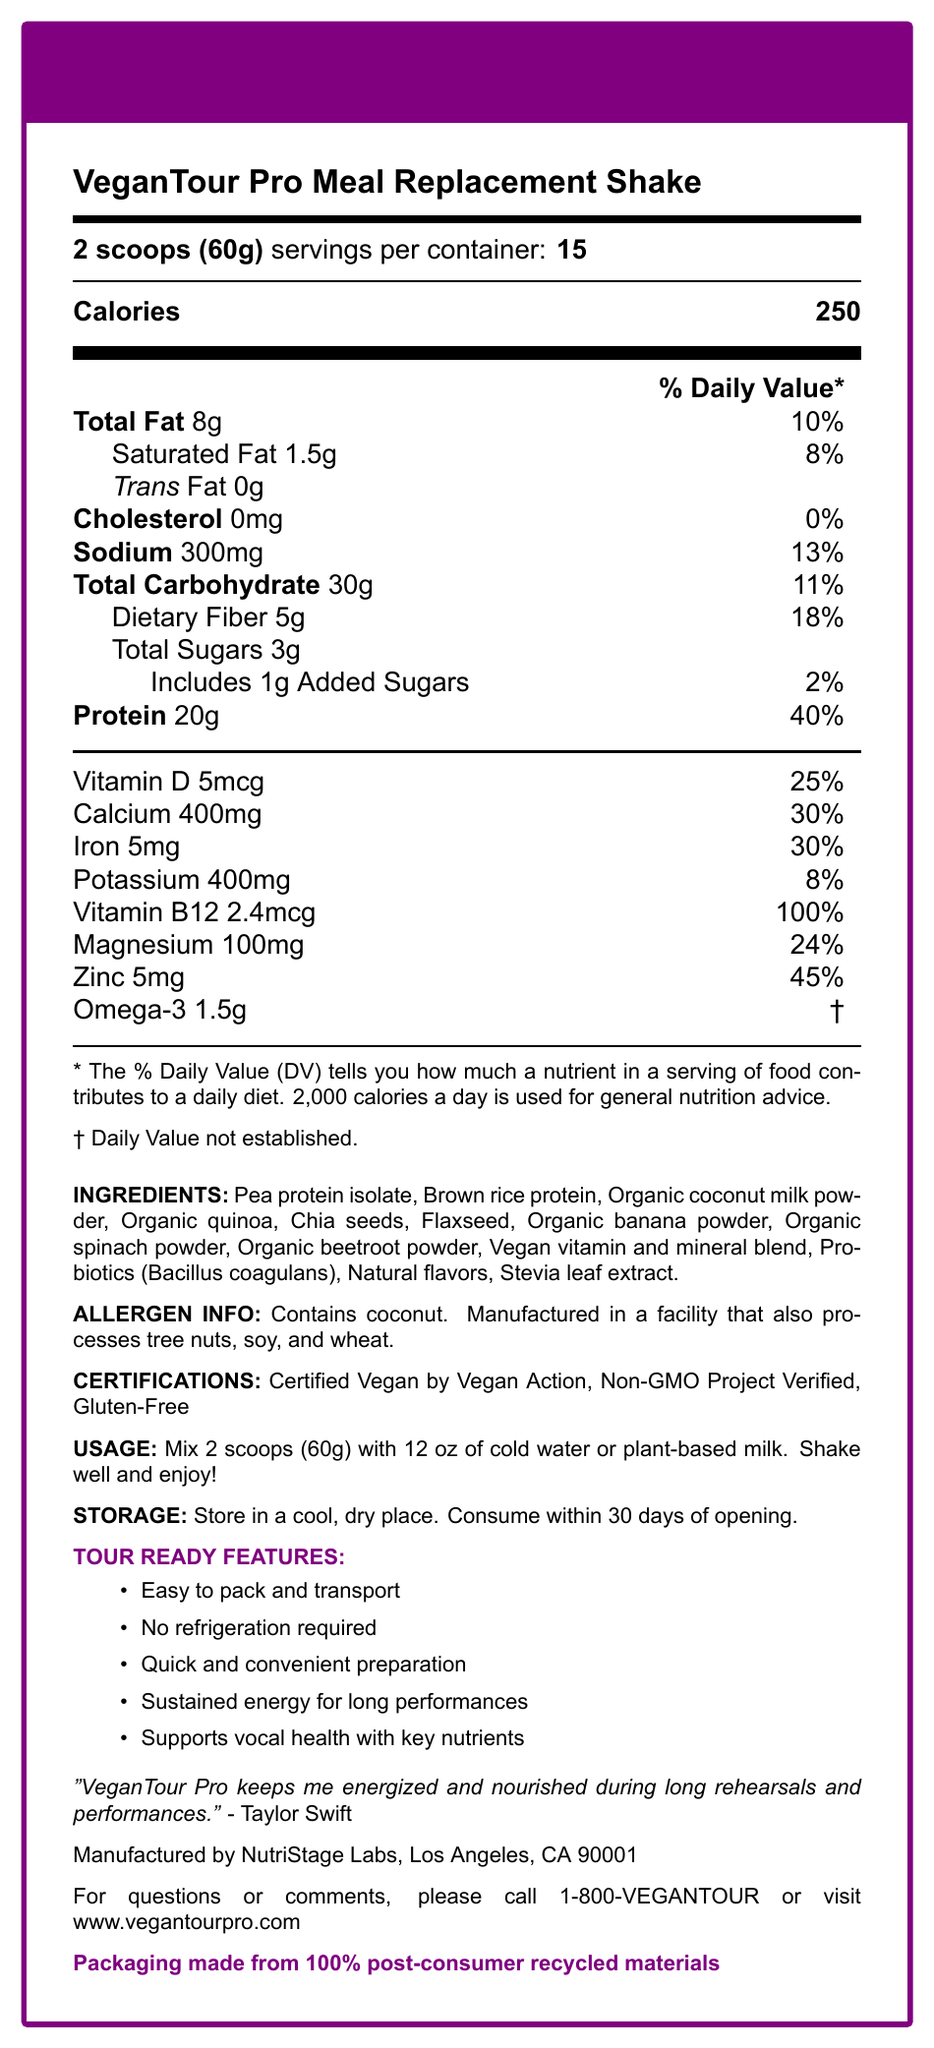what is the serving size for the VeganTour Pro Meal Replacement Shake? The serving size is explicitly mentioned as "2 scoops (60g)" in the document.
Answer: 2 scoops (60g) how many servings are there per container? The document states that there are 15 servings per container.
Answer: 15 what is the calorie count per serving? The calorie count per serving is listed as 250 in the document.
Answer: 250 how much protein does one serving contain? The protein content per serving is stated as 20g.
Answer: 20g how much sodium is in each serving? The sodium content per serving is indicated as 300mg.
Answer: 300mg what is the allergen information provided? The allergen information section states that the product contains coconut and is manufactured in a facility that also processes tree nuts, soy, and wheat.
Answer: Contains coconut. Manufactured in a facility that also processes tree nuts, soy, and wheat. what is the percentage of the Daily Value for Vitamin D in each serving? The document lists the Daily Value percentage for Vitamin D as 25%.
Answer: 25% which artist provided a testimonial for the VeganTour Pro Shake? A. Beyoncé B. Taylor Swift C. Katy Perry D. Lady Gaga The document includes a testimonial from Taylor Swift.
Answer: B what is the primary source of protein in the product? The ingredients list shows Pea protein isolate and Brown rice protein as the primary sources of protein.
Answer: Pea protein isolate and Brown rice protein which certification does the product have? A. USDA Organic B. Non-GMO Project Verified C. Gluten-Free D. B and C The document states that the product is Certified Vegan by Vegan Action, Non-GMO Project Verified, and Gluten-Free. Among the options, only B and C are listed.
Answer: D is this product suitable for vegans? The product is certified vegan as indicated by the certification section.
Answer: Yes how long can the product be consumed safely after opening? The storage instructions mention that the product should be consumed within 30 days of opening.
Answer: 30 days summarize the main features of the VeganTour Pro Meal Replacement Shake. The summary reflects the main features and benefits, including nutritional content, certifications, and practical aspects for touring artists.
Answer: The VeganTour Pro Meal Replacement Shake is a vegan, non-GMO, and gluten-free meal replacement designed for touring artists. It offers 250 calories per serving and includes essential nutrients like protein, vitamins, and minerals. The shake is easy to pack and transport, requires no refrigeration, and supports sustained energy and vocal health. The product contains coconut and is manufactured in a facility that processes tree nuts, soy, and wheat. is the amount of potassium listed as 300mg? The document lists the potassium amount as 400mg, not 300mg.
Answer: No how many grams of added sugars are in each serving? The document specifies that there is 1g of added sugars in each serving.
Answer: 1g who manufactures the VeganTour Pro Shake? The manufacturer is listed as NutriStage Labs, Los Angeles, CA 90001 at the bottom of the document.
Answer: NutriStage Labs, Los Angeles, CA 90001 what is the total fat content as a percentage of the Daily Value? The total fat content is listed as 8g, which is 10% of the Daily Value.
Answer: 10% where is the product’s packaging made from? The sustainability note mentions that the packaging is made from 100% post-consumer recycled materials.
Answer: 100% post-consumer recycled materials what is the recommended mixing liquid for the VeganTour Pro Shake? The usage instructions recommend mixing the product with cold water or plant-based milk.
Answer: Cold water or plant-based milk what is the total carbohydrate content per serving? The total carbohydrate content per serving is listed as 30g.
Answer: 30g 